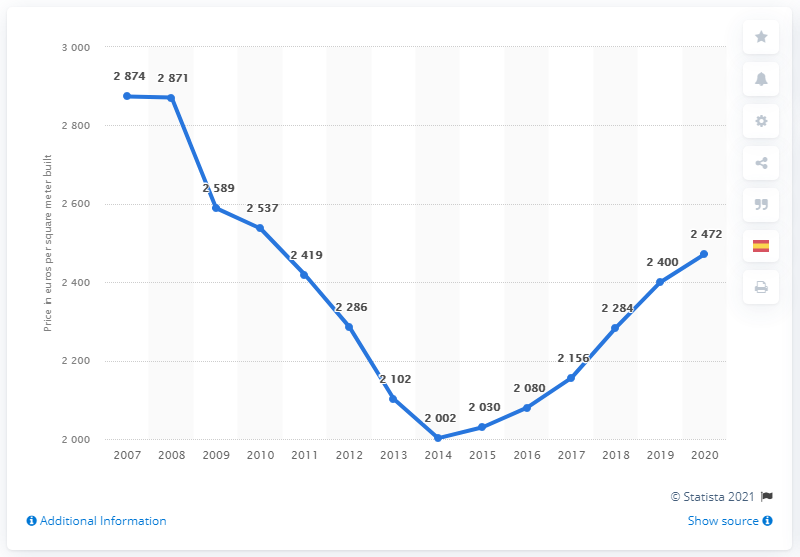Mention a couple of crucial points in this snapshot. In 2007, the global financial crisis hit Spain. It is estimated that the cost of building a new house in Spain in 2020 is approximately 24,720 euros. 